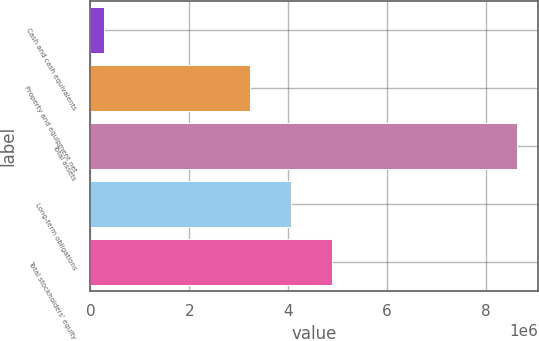Convert chart. <chart><loc_0><loc_0><loc_500><loc_500><bar_chart><fcel>Cash and cash equivalents<fcel>Property and equipment net<fcel>Total assets<fcel>Long-term obligations<fcel>Total stockholders' equity<nl><fcel>281264<fcel>3.21812e+06<fcel>8.61322e+06<fcel>4.05132e+06<fcel>4.88452e+06<nl></chart> 